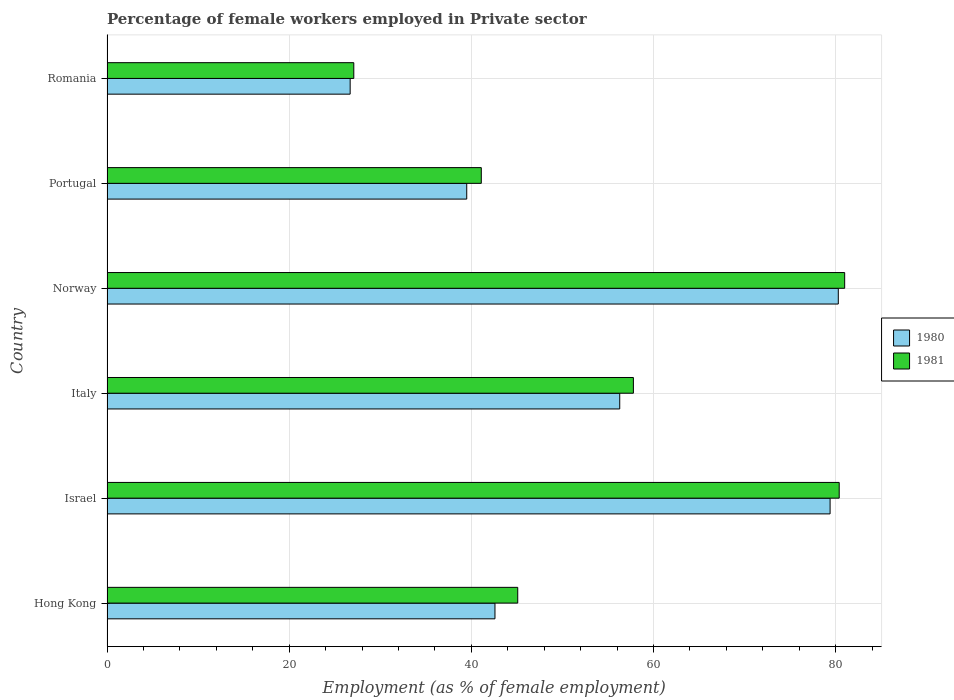How many groups of bars are there?
Provide a succinct answer. 6. Are the number of bars per tick equal to the number of legend labels?
Offer a terse response. Yes. How many bars are there on the 2nd tick from the top?
Your answer should be very brief. 2. How many bars are there on the 2nd tick from the bottom?
Keep it short and to the point. 2. What is the percentage of females employed in Private sector in 1981 in Israel?
Make the answer very short. 80.4. Across all countries, what is the maximum percentage of females employed in Private sector in 1980?
Keep it short and to the point. 80.3. Across all countries, what is the minimum percentage of females employed in Private sector in 1980?
Your answer should be compact. 26.7. In which country was the percentage of females employed in Private sector in 1980 maximum?
Make the answer very short. Norway. In which country was the percentage of females employed in Private sector in 1980 minimum?
Offer a terse response. Romania. What is the total percentage of females employed in Private sector in 1981 in the graph?
Offer a very short reply. 332.5. What is the difference between the percentage of females employed in Private sector in 1980 in Italy and that in Romania?
Give a very brief answer. 29.6. What is the difference between the percentage of females employed in Private sector in 1981 in Italy and the percentage of females employed in Private sector in 1980 in Norway?
Make the answer very short. -22.5. What is the average percentage of females employed in Private sector in 1980 per country?
Your answer should be compact. 54.13. What is the difference between the percentage of females employed in Private sector in 1981 and percentage of females employed in Private sector in 1980 in Norway?
Ensure brevity in your answer.  0.7. In how many countries, is the percentage of females employed in Private sector in 1980 greater than 56 %?
Offer a very short reply. 3. What is the ratio of the percentage of females employed in Private sector in 1981 in Italy to that in Norway?
Your response must be concise. 0.71. Is the percentage of females employed in Private sector in 1981 in Hong Kong less than that in Norway?
Make the answer very short. Yes. Is the difference between the percentage of females employed in Private sector in 1981 in Israel and Norway greater than the difference between the percentage of females employed in Private sector in 1980 in Israel and Norway?
Give a very brief answer. Yes. What is the difference between the highest and the second highest percentage of females employed in Private sector in 1981?
Make the answer very short. 0.6. What is the difference between the highest and the lowest percentage of females employed in Private sector in 1980?
Your answer should be very brief. 53.6. In how many countries, is the percentage of females employed in Private sector in 1980 greater than the average percentage of females employed in Private sector in 1980 taken over all countries?
Give a very brief answer. 3. Is the sum of the percentage of females employed in Private sector in 1980 in Italy and Portugal greater than the maximum percentage of females employed in Private sector in 1981 across all countries?
Provide a short and direct response. Yes. What does the 1st bar from the top in Israel represents?
Your response must be concise. 1981. What does the 1st bar from the bottom in Portugal represents?
Provide a short and direct response. 1980. How many bars are there?
Provide a short and direct response. 12. How many countries are there in the graph?
Offer a terse response. 6. Are the values on the major ticks of X-axis written in scientific E-notation?
Give a very brief answer. No. How are the legend labels stacked?
Your response must be concise. Vertical. What is the title of the graph?
Your response must be concise. Percentage of female workers employed in Private sector. Does "1961" appear as one of the legend labels in the graph?
Your answer should be very brief. No. What is the label or title of the X-axis?
Make the answer very short. Employment (as % of female employment). What is the label or title of the Y-axis?
Give a very brief answer. Country. What is the Employment (as % of female employment) of 1980 in Hong Kong?
Provide a short and direct response. 42.6. What is the Employment (as % of female employment) in 1981 in Hong Kong?
Make the answer very short. 45.1. What is the Employment (as % of female employment) of 1980 in Israel?
Give a very brief answer. 79.4. What is the Employment (as % of female employment) in 1981 in Israel?
Keep it short and to the point. 80.4. What is the Employment (as % of female employment) in 1980 in Italy?
Make the answer very short. 56.3. What is the Employment (as % of female employment) of 1981 in Italy?
Your answer should be compact. 57.8. What is the Employment (as % of female employment) in 1980 in Norway?
Your answer should be compact. 80.3. What is the Employment (as % of female employment) in 1981 in Norway?
Keep it short and to the point. 81. What is the Employment (as % of female employment) in 1980 in Portugal?
Provide a succinct answer. 39.5. What is the Employment (as % of female employment) of 1981 in Portugal?
Your answer should be compact. 41.1. What is the Employment (as % of female employment) of 1980 in Romania?
Offer a very short reply. 26.7. What is the Employment (as % of female employment) in 1981 in Romania?
Offer a very short reply. 27.1. Across all countries, what is the maximum Employment (as % of female employment) of 1980?
Provide a succinct answer. 80.3. Across all countries, what is the minimum Employment (as % of female employment) of 1980?
Your response must be concise. 26.7. Across all countries, what is the minimum Employment (as % of female employment) of 1981?
Offer a terse response. 27.1. What is the total Employment (as % of female employment) in 1980 in the graph?
Make the answer very short. 324.8. What is the total Employment (as % of female employment) of 1981 in the graph?
Your answer should be compact. 332.5. What is the difference between the Employment (as % of female employment) of 1980 in Hong Kong and that in Israel?
Offer a very short reply. -36.8. What is the difference between the Employment (as % of female employment) of 1981 in Hong Kong and that in Israel?
Offer a terse response. -35.3. What is the difference between the Employment (as % of female employment) in 1980 in Hong Kong and that in Italy?
Make the answer very short. -13.7. What is the difference between the Employment (as % of female employment) in 1980 in Hong Kong and that in Norway?
Ensure brevity in your answer.  -37.7. What is the difference between the Employment (as % of female employment) in 1981 in Hong Kong and that in Norway?
Your answer should be compact. -35.9. What is the difference between the Employment (as % of female employment) of 1980 in Hong Kong and that in Portugal?
Offer a very short reply. 3.1. What is the difference between the Employment (as % of female employment) in 1981 in Hong Kong and that in Portugal?
Your response must be concise. 4. What is the difference between the Employment (as % of female employment) in 1980 in Hong Kong and that in Romania?
Give a very brief answer. 15.9. What is the difference between the Employment (as % of female employment) in 1980 in Israel and that in Italy?
Offer a very short reply. 23.1. What is the difference between the Employment (as % of female employment) of 1981 in Israel and that in Italy?
Your answer should be very brief. 22.6. What is the difference between the Employment (as % of female employment) of 1981 in Israel and that in Norway?
Keep it short and to the point. -0.6. What is the difference between the Employment (as % of female employment) in 1980 in Israel and that in Portugal?
Your answer should be very brief. 39.9. What is the difference between the Employment (as % of female employment) of 1981 in Israel and that in Portugal?
Keep it short and to the point. 39.3. What is the difference between the Employment (as % of female employment) in 1980 in Israel and that in Romania?
Your answer should be very brief. 52.7. What is the difference between the Employment (as % of female employment) of 1981 in Israel and that in Romania?
Your response must be concise. 53.3. What is the difference between the Employment (as % of female employment) of 1981 in Italy and that in Norway?
Offer a very short reply. -23.2. What is the difference between the Employment (as % of female employment) in 1980 in Italy and that in Portugal?
Make the answer very short. 16.8. What is the difference between the Employment (as % of female employment) of 1980 in Italy and that in Romania?
Provide a short and direct response. 29.6. What is the difference between the Employment (as % of female employment) in 1981 in Italy and that in Romania?
Give a very brief answer. 30.7. What is the difference between the Employment (as % of female employment) of 1980 in Norway and that in Portugal?
Make the answer very short. 40.8. What is the difference between the Employment (as % of female employment) of 1981 in Norway and that in Portugal?
Make the answer very short. 39.9. What is the difference between the Employment (as % of female employment) of 1980 in Norway and that in Romania?
Provide a short and direct response. 53.6. What is the difference between the Employment (as % of female employment) in 1981 in Norway and that in Romania?
Ensure brevity in your answer.  53.9. What is the difference between the Employment (as % of female employment) of 1980 in Hong Kong and the Employment (as % of female employment) of 1981 in Israel?
Your answer should be compact. -37.8. What is the difference between the Employment (as % of female employment) of 1980 in Hong Kong and the Employment (as % of female employment) of 1981 in Italy?
Keep it short and to the point. -15.2. What is the difference between the Employment (as % of female employment) of 1980 in Hong Kong and the Employment (as % of female employment) of 1981 in Norway?
Your answer should be compact. -38.4. What is the difference between the Employment (as % of female employment) of 1980 in Hong Kong and the Employment (as % of female employment) of 1981 in Portugal?
Provide a succinct answer. 1.5. What is the difference between the Employment (as % of female employment) in 1980 in Israel and the Employment (as % of female employment) in 1981 in Italy?
Give a very brief answer. 21.6. What is the difference between the Employment (as % of female employment) in 1980 in Israel and the Employment (as % of female employment) in 1981 in Norway?
Keep it short and to the point. -1.6. What is the difference between the Employment (as % of female employment) in 1980 in Israel and the Employment (as % of female employment) in 1981 in Portugal?
Make the answer very short. 38.3. What is the difference between the Employment (as % of female employment) of 1980 in Israel and the Employment (as % of female employment) of 1981 in Romania?
Your answer should be compact. 52.3. What is the difference between the Employment (as % of female employment) in 1980 in Italy and the Employment (as % of female employment) in 1981 in Norway?
Make the answer very short. -24.7. What is the difference between the Employment (as % of female employment) in 1980 in Italy and the Employment (as % of female employment) in 1981 in Romania?
Provide a short and direct response. 29.2. What is the difference between the Employment (as % of female employment) in 1980 in Norway and the Employment (as % of female employment) in 1981 in Portugal?
Provide a succinct answer. 39.2. What is the difference between the Employment (as % of female employment) of 1980 in Norway and the Employment (as % of female employment) of 1981 in Romania?
Provide a short and direct response. 53.2. What is the average Employment (as % of female employment) of 1980 per country?
Your answer should be very brief. 54.13. What is the average Employment (as % of female employment) of 1981 per country?
Provide a succinct answer. 55.42. What is the difference between the Employment (as % of female employment) in 1980 and Employment (as % of female employment) in 1981 in Hong Kong?
Offer a terse response. -2.5. What is the difference between the Employment (as % of female employment) of 1980 and Employment (as % of female employment) of 1981 in Italy?
Ensure brevity in your answer.  -1.5. What is the ratio of the Employment (as % of female employment) in 1980 in Hong Kong to that in Israel?
Your answer should be compact. 0.54. What is the ratio of the Employment (as % of female employment) of 1981 in Hong Kong to that in Israel?
Your answer should be compact. 0.56. What is the ratio of the Employment (as % of female employment) in 1980 in Hong Kong to that in Italy?
Offer a very short reply. 0.76. What is the ratio of the Employment (as % of female employment) in 1981 in Hong Kong to that in Italy?
Provide a succinct answer. 0.78. What is the ratio of the Employment (as % of female employment) in 1980 in Hong Kong to that in Norway?
Provide a succinct answer. 0.53. What is the ratio of the Employment (as % of female employment) in 1981 in Hong Kong to that in Norway?
Give a very brief answer. 0.56. What is the ratio of the Employment (as % of female employment) in 1980 in Hong Kong to that in Portugal?
Your response must be concise. 1.08. What is the ratio of the Employment (as % of female employment) in 1981 in Hong Kong to that in Portugal?
Your response must be concise. 1.1. What is the ratio of the Employment (as % of female employment) of 1980 in Hong Kong to that in Romania?
Your answer should be very brief. 1.6. What is the ratio of the Employment (as % of female employment) of 1981 in Hong Kong to that in Romania?
Your answer should be very brief. 1.66. What is the ratio of the Employment (as % of female employment) of 1980 in Israel to that in Italy?
Your response must be concise. 1.41. What is the ratio of the Employment (as % of female employment) in 1981 in Israel to that in Italy?
Give a very brief answer. 1.39. What is the ratio of the Employment (as % of female employment) of 1980 in Israel to that in Norway?
Offer a very short reply. 0.99. What is the ratio of the Employment (as % of female employment) in 1980 in Israel to that in Portugal?
Provide a succinct answer. 2.01. What is the ratio of the Employment (as % of female employment) of 1981 in Israel to that in Portugal?
Provide a succinct answer. 1.96. What is the ratio of the Employment (as % of female employment) in 1980 in Israel to that in Romania?
Your answer should be very brief. 2.97. What is the ratio of the Employment (as % of female employment) in 1981 in Israel to that in Romania?
Provide a succinct answer. 2.97. What is the ratio of the Employment (as % of female employment) of 1980 in Italy to that in Norway?
Your answer should be compact. 0.7. What is the ratio of the Employment (as % of female employment) in 1981 in Italy to that in Norway?
Make the answer very short. 0.71. What is the ratio of the Employment (as % of female employment) of 1980 in Italy to that in Portugal?
Give a very brief answer. 1.43. What is the ratio of the Employment (as % of female employment) of 1981 in Italy to that in Portugal?
Your answer should be compact. 1.41. What is the ratio of the Employment (as % of female employment) of 1980 in Italy to that in Romania?
Ensure brevity in your answer.  2.11. What is the ratio of the Employment (as % of female employment) of 1981 in Italy to that in Romania?
Keep it short and to the point. 2.13. What is the ratio of the Employment (as % of female employment) in 1980 in Norway to that in Portugal?
Give a very brief answer. 2.03. What is the ratio of the Employment (as % of female employment) of 1981 in Norway to that in Portugal?
Offer a very short reply. 1.97. What is the ratio of the Employment (as % of female employment) of 1980 in Norway to that in Romania?
Your answer should be very brief. 3.01. What is the ratio of the Employment (as % of female employment) in 1981 in Norway to that in Romania?
Ensure brevity in your answer.  2.99. What is the ratio of the Employment (as % of female employment) of 1980 in Portugal to that in Romania?
Provide a short and direct response. 1.48. What is the ratio of the Employment (as % of female employment) in 1981 in Portugal to that in Romania?
Provide a short and direct response. 1.52. What is the difference between the highest and the second highest Employment (as % of female employment) of 1981?
Provide a succinct answer. 0.6. What is the difference between the highest and the lowest Employment (as % of female employment) of 1980?
Make the answer very short. 53.6. What is the difference between the highest and the lowest Employment (as % of female employment) in 1981?
Offer a very short reply. 53.9. 